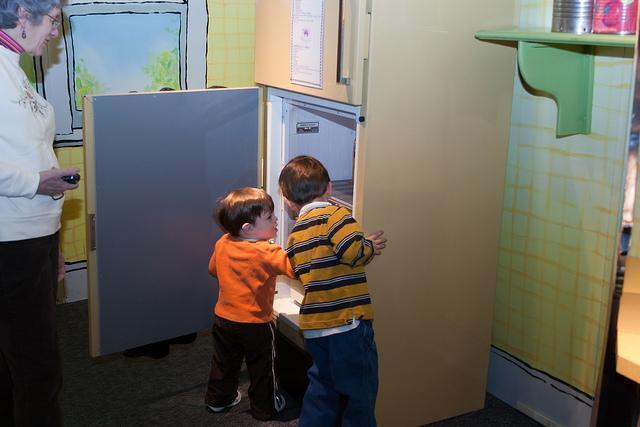The wall decoration and props here are modeled after which location?
Indicate the correct response by choosing from the four available options to answer the question.
Options: Garage, living room, bedroom, kitchen. Kitchen. 